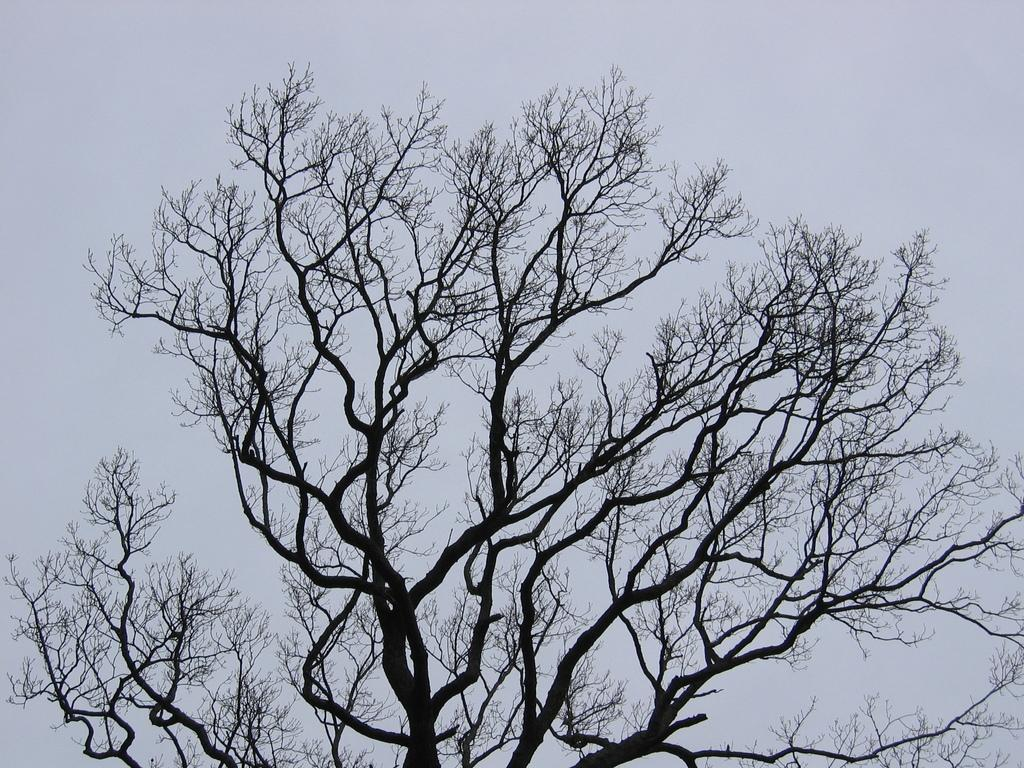What is the main object in the image? There is a tree in the image. What is the condition of the tree in the image? The tree does not have leaves. What type of meat is being discussed by the person in the image? There is no person present in the image, and therefore no discussion or meat can be observed. 